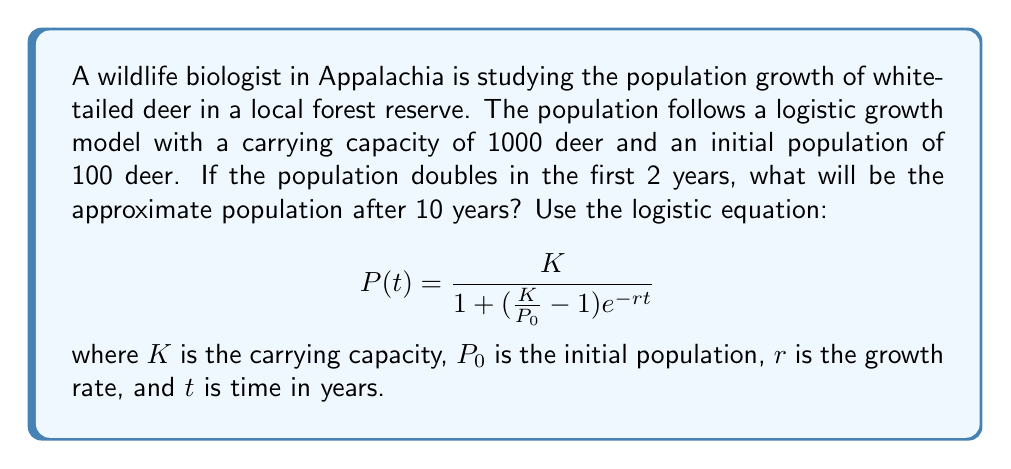Can you solve this math problem? To solve this problem, we'll follow these steps:

1. First, we need to find the growth rate $r$ using the given information:
   - $K = 1000$ (carrying capacity)
   - $P_0 = 100$ (initial population)
   - Population doubles in 2 years, so $P(2) = 200$

2. Plug these values into the logistic equation:

   $$200 = \frac{1000}{1 + (\frac{1000}{100} - 1)e^{-2r}}$$

3. Simplify and solve for $r$:

   $$200 = \frac{1000}{1 + 9e^{-2r}}$$
   $$5 = 1 + 9e^{-2r}$$
   $$4 = 9e^{-2r}$$
   $$\frac{4}{9} = e^{-2r}$$
   $$\ln(\frac{4}{9}) = -2r$$
   $$r = -\frac{1}{2}\ln(\frac{4}{9}) \approx 0.4055$$

4. Now that we have $r$, we can find the population after 10 years by plugging in $t = 10$ into the logistic equation:

   $$P(10) = \frac{1000}{1 + (\frac{1000}{100} - 1)e^{-0.4055 \cdot 10}}$$

5. Simplify and calculate:

   $$P(10) = \frac{1000}{1 + 9e^{-4.055}} \approx 915.37$$

6. Round to the nearest whole number since we're dealing with a deer population.
Answer: 915 deer 